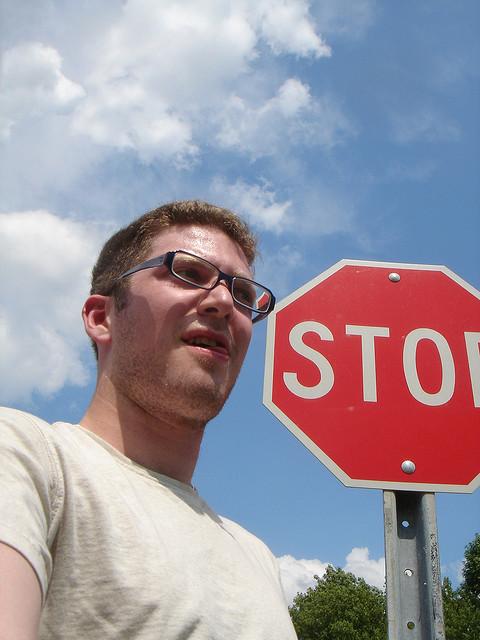What is red in this picture?
Keep it brief. Stop sign. What does the sign say to do?
Write a very short answer. Stop. Overcast or sunny?
Answer briefly. Sunny. 